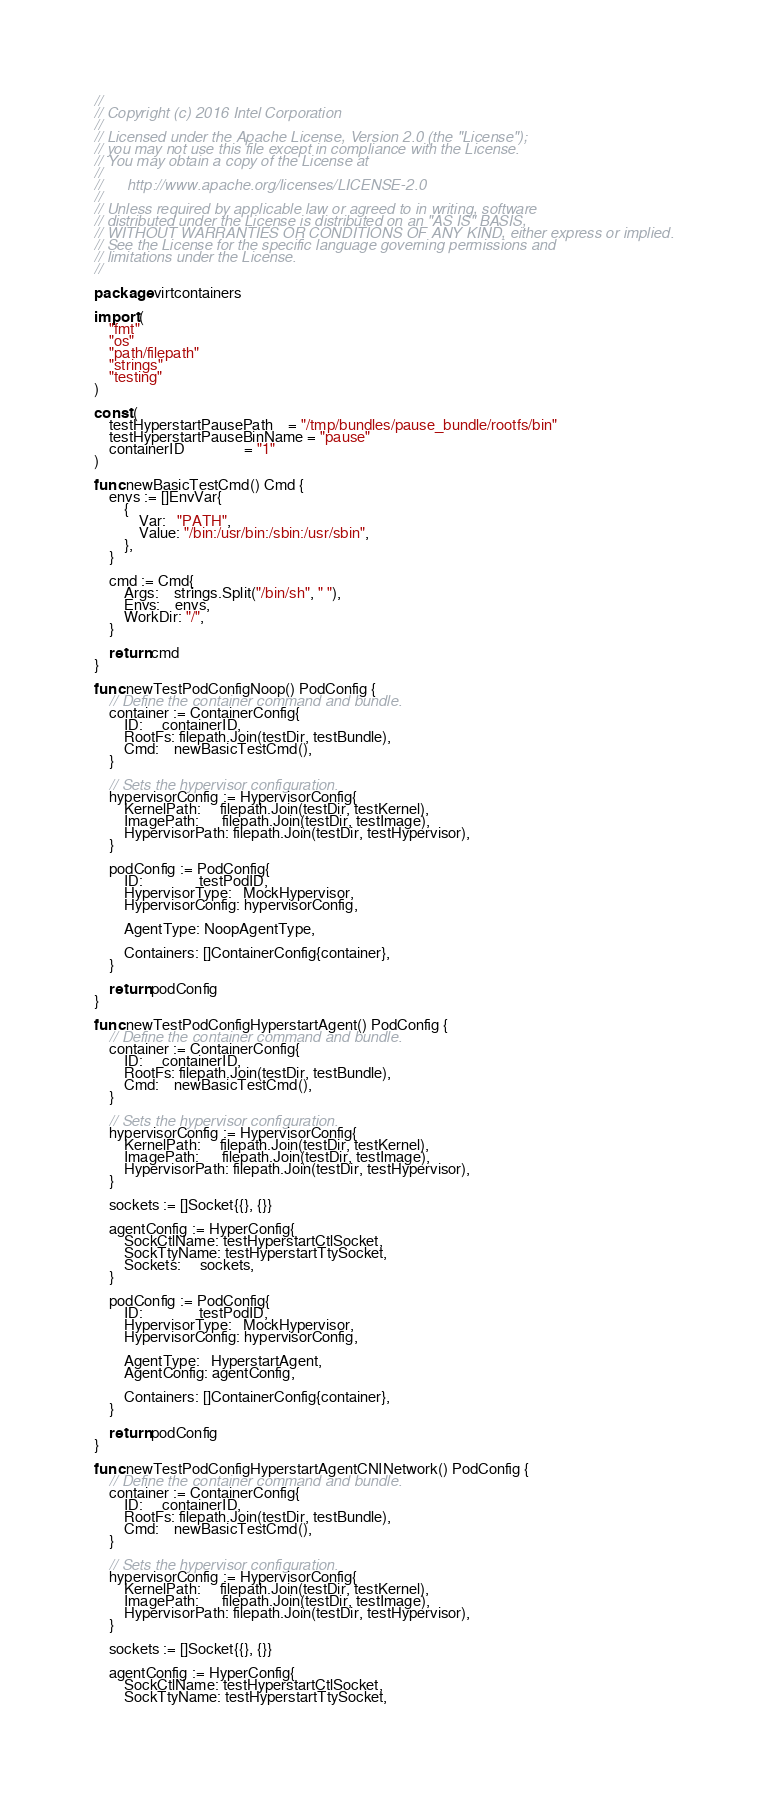Convert code to text. <code><loc_0><loc_0><loc_500><loc_500><_Go_>//
// Copyright (c) 2016 Intel Corporation
//
// Licensed under the Apache License, Version 2.0 (the "License");
// you may not use this file except in compliance with the License.
// You may obtain a copy of the License at
//
//      http://www.apache.org/licenses/LICENSE-2.0
//
// Unless required by applicable law or agreed to in writing, software
// distributed under the License is distributed on an "AS IS" BASIS,
// WITHOUT WARRANTIES OR CONDITIONS OF ANY KIND, either express or implied.
// See the License for the specific language governing permissions and
// limitations under the License.
//

package virtcontainers

import (
	"fmt"
	"os"
	"path/filepath"
	"strings"
	"testing"
)

const (
	testHyperstartPausePath    = "/tmp/bundles/pause_bundle/rootfs/bin"
	testHyperstartPauseBinName = "pause"
	containerID                = "1"
)

func newBasicTestCmd() Cmd {
	envs := []EnvVar{
		{
			Var:   "PATH",
			Value: "/bin:/usr/bin:/sbin:/usr/sbin",
		},
	}

	cmd := Cmd{
		Args:    strings.Split("/bin/sh", " "),
		Envs:    envs,
		WorkDir: "/",
	}

	return cmd
}

func newTestPodConfigNoop() PodConfig {
	// Define the container command and bundle.
	container := ContainerConfig{
		ID:     containerID,
		RootFs: filepath.Join(testDir, testBundle),
		Cmd:    newBasicTestCmd(),
	}

	// Sets the hypervisor configuration.
	hypervisorConfig := HypervisorConfig{
		KernelPath:     filepath.Join(testDir, testKernel),
		ImagePath:      filepath.Join(testDir, testImage),
		HypervisorPath: filepath.Join(testDir, testHypervisor),
	}

	podConfig := PodConfig{
		ID:               testPodID,
		HypervisorType:   MockHypervisor,
		HypervisorConfig: hypervisorConfig,

		AgentType: NoopAgentType,

		Containers: []ContainerConfig{container},
	}

	return podConfig
}

func newTestPodConfigHyperstartAgent() PodConfig {
	// Define the container command and bundle.
	container := ContainerConfig{
		ID:     containerID,
		RootFs: filepath.Join(testDir, testBundle),
		Cmd:    newBasicTestCmd(),
	}

	// Sets the hypervisor configuration.
	hypervisorConfig := HypervisorConfig{
		KernelPath:     filepath.Join(testDir, testKernel),
		ImagePath:      filepath.Join(testDir, testImage),
		HypervisorPath: filepath.Join(testDir, testHypervisor),
	}

	sockets := []Socket{{}, {}}

	agentConfig := HyperConfig{
		SockCtlName: testHyperstartCtlSocket,
		SockTtyName: testHyperstartTtySocket,
		Sockets:     sockets,
	}

	podConfig := PodConfig{
		ID:               testPodID,
		HypervisorType:   MockHypervisor,
		HypervisorConfig: hypervisorConfig,

		AgentType:   HyperstartAgent,
		AgentConfig: agentConfig,

		Containers: []ContainerConfig{container},
	}

	return podConfig
}

func newTestPodConfigHyperstartAgentCNINetwork() PodConfig {
	// Define the container command and bundle.
	container := ContainerConfig{
		ID:     containerID,
		RootFs: filepath.Join(testDir, testBundle),
		Cmd:    newBasicTestCmd(),
	}

	// Sets the hypervisor configuration.
	hypervisorConfig := HypervisorConfig{
		KernelPath:     filepath.Join(testDir, testKernel),
		ImagePath:      filepath.Join(testDir, testImage),
		HypervisorPath: filepath.Join(testDir, testHypervisor),
	}

	sockets := []Socket{{}, {}}

	agentConfig := HyperConfig{
		SockCtlName: testHyperstartCtlSocket,
		SockTtyName: testHyperstartTtySocket,</code> 